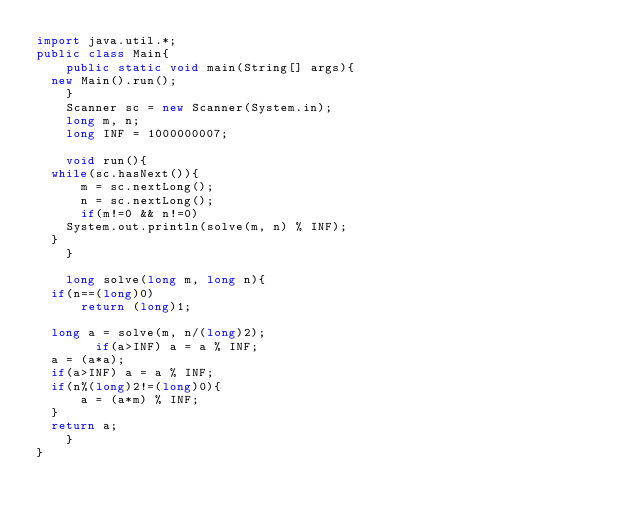Convert code to text. <code><loc_0><loc_0><loc_500><loc_500><_Java_>import java.util.*;
public class Main{
    public static void main(String[] args){
	new Main().run();
    }
    Scanner sc = new Scanner(System.in);
    long m, n;
    long INF = 1000000007;

    void run(){
	while(sc.hasNext()){
	    m = sc.nextLong();
	    n = sc.nextLong();
	    if(m!=0 && n!=0) 
		System.out.println(solve(m, n) % INF);
	}
    }
    
    long solve(long m, long n){
	if(n==(long)0)
	    return (long)1;
	
	long a = solve(m, n/(long)2);
        if(a>INF) a = a % INF;
	a = (a*a);
	if(a>INF) a = a % INF;
	if(n%(long)2!=(long)0){
	    a = (a*m) % INF;
	}
	return a;
    }
}</code> 